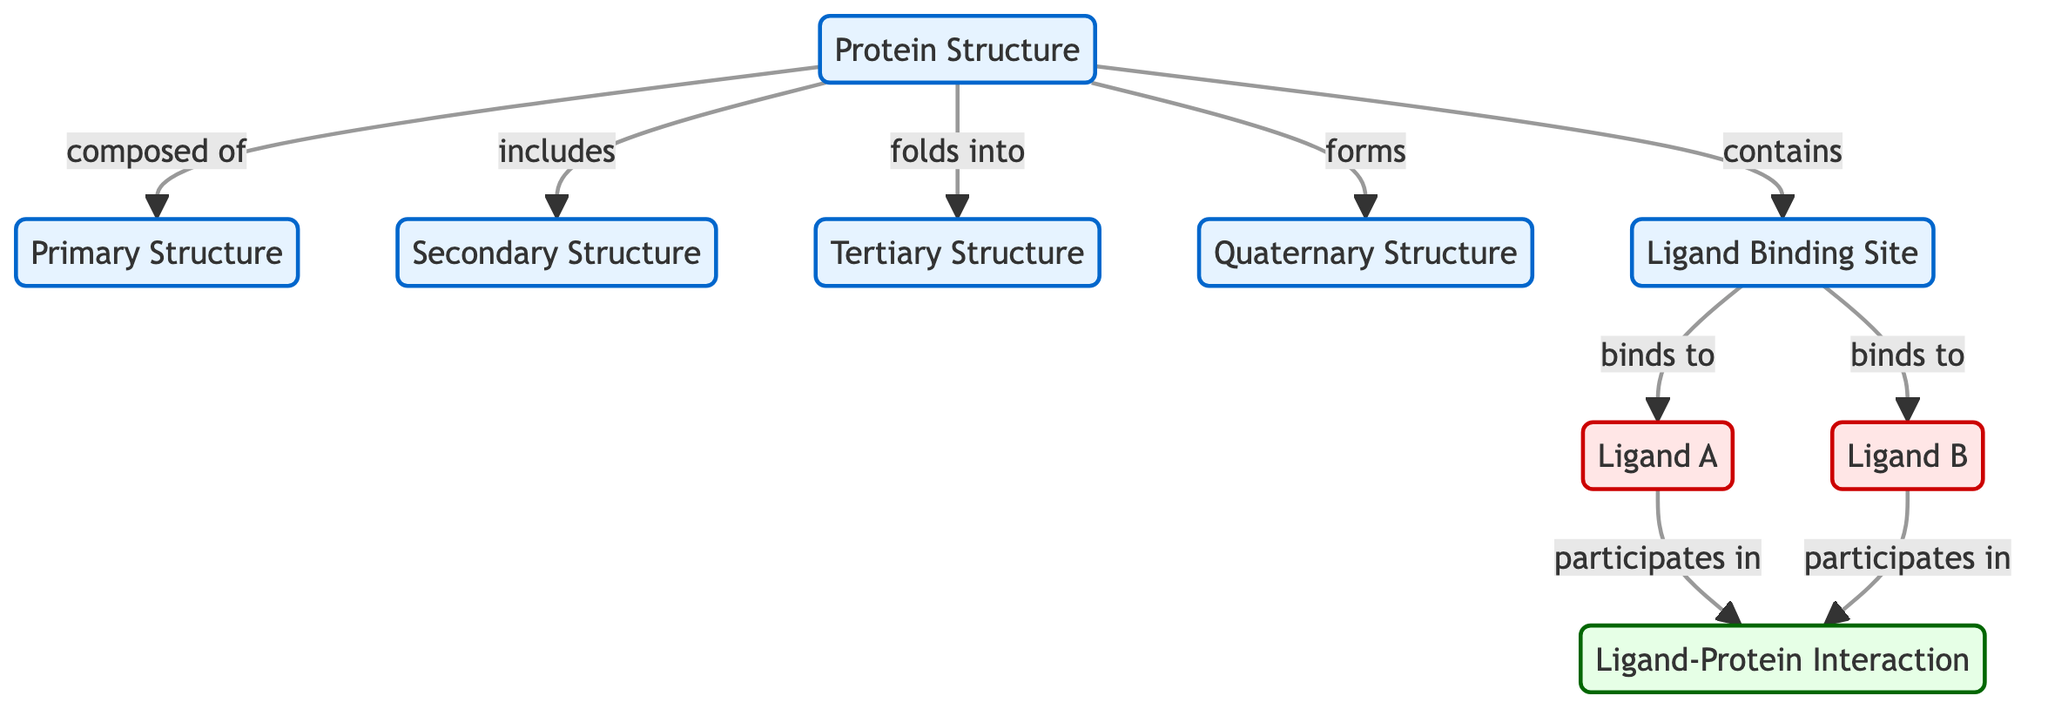What are the four structures of a protein depicted in the diagram? The diagram includes the Primary Structure, Secondary Structure, Tertiary Structure, and Quaternary Structure, all of which are represented as nodes connecting to the Protein Structure node.
Answer: Primary Structure, Secondary Structure, Tertiary Structure, Quaternary Structure How many ligands are shown in the diagram? There are two ligands presented in the diagram: Ligand A and Ligand B. Each ligand has its own node connected to the Ligand Binding Site node.
Answer: 2 What is the Ligand Binding Site connected to? The Ligand Binding Site (LBS) connects to two ligands: Ligand A and Ligand B, according to the directional arrows pointing from LBS to each ligand node.
Answer: Ligand A, Ligand B Which structural level is considered the Protein Structure's highest level of organization? The diagram illustrates that the Quaternary Structure is the highest level of organization under the Protein Structure node. This is indicated by the directional connection from the Protein Structure node to the Quaternary Structure node.
Answer: Quaternary Structure Which ligands participate in the Ligand-Protein Interaction? Ligand A and Ligand B both participate in the Ligand-Protein Interaction as depicted by the arrows pointing from each ligand to the Ligand-Protein Interaction node.
Answer: Ligand A, Ligand B What does the Ligand Binding Site do? The Ligand Binding Site acts as a binding point for Ligand A and Ligand B, as indicated by the arrows from the LBS node to the ligands.
Answer: Binds to Ligand A, Binds to Ligand B How many connections does the Protein Structure have to other nodes? The Protein Structure node connects to five other nodes: the Primary, Secondary, Tertiary, Quaternary structures, and the Ligand Binding Site, which totals five connections represented by the arrows leaving the Protein Structure node.
Answer: 5 What interaction do both ligands participate in? Both Ligand A and Ligand B participate in the Ligand-Protein Interaction, as indicated by their respective connections to the interaction node in the diagram.
Answer: Ligand-Protein Interaction 